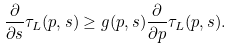Convert formula to latex. <formula><loc_0><loc_0><loc_500><loc_500>\frac { \partial } { \partial s } \tau _ { L } ( p , s ) \geq g ( p , s ) \frac { \partial } { \partial p } \tau _ { L } ( p , s ) .</formula> 